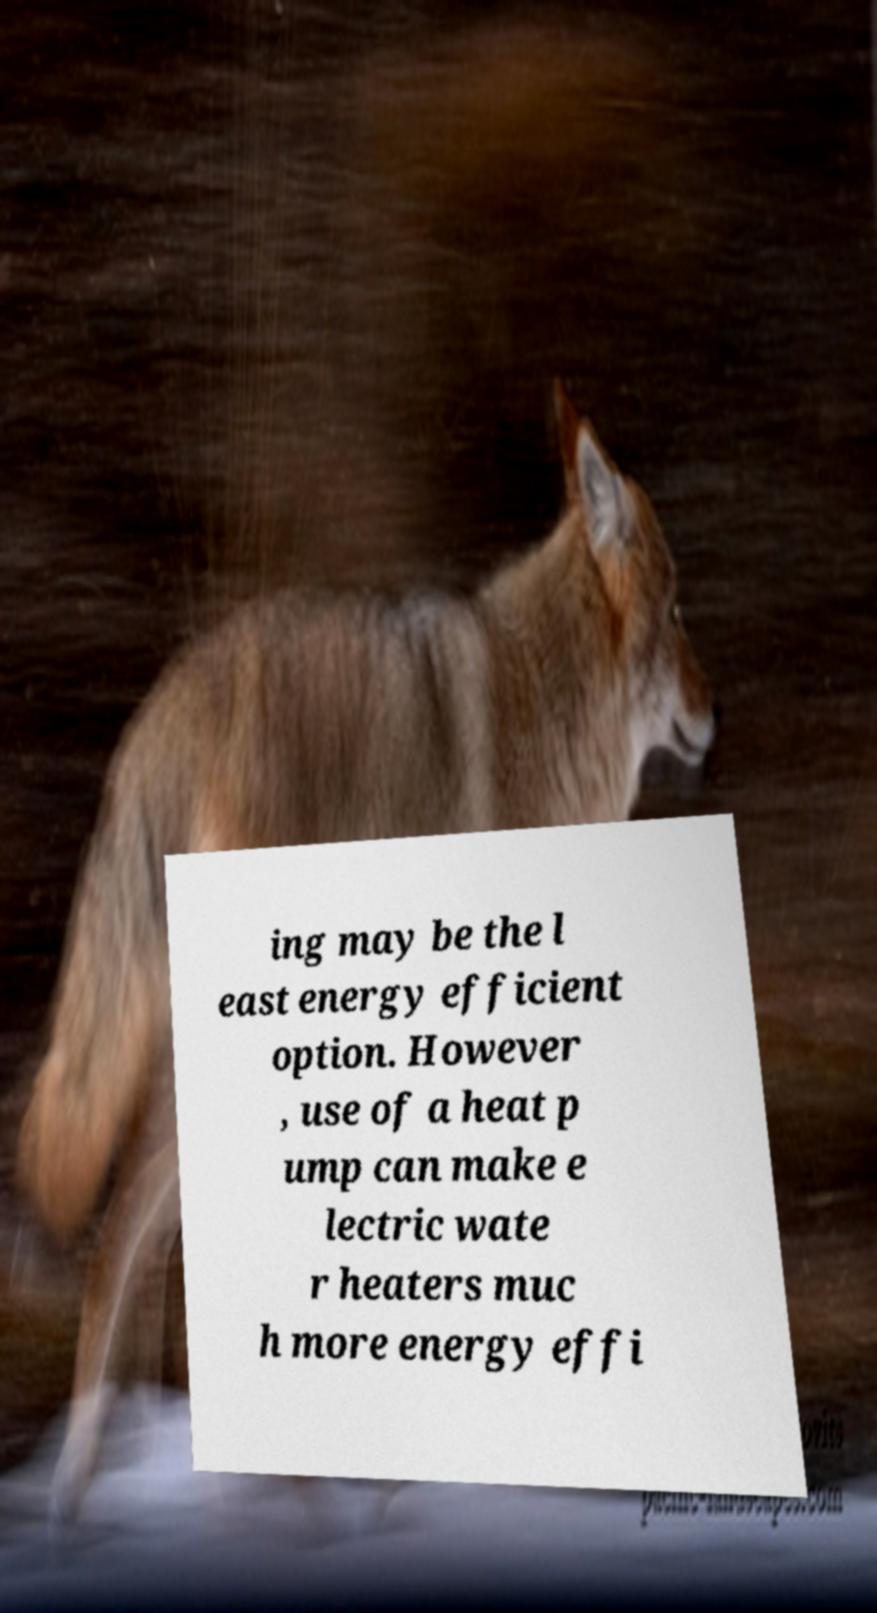Could you extract and type out the text from this image? ing may be the l east energy efficient option. However , use of a heat p ump can make e lectric wate r heaters muc h more energy effi 